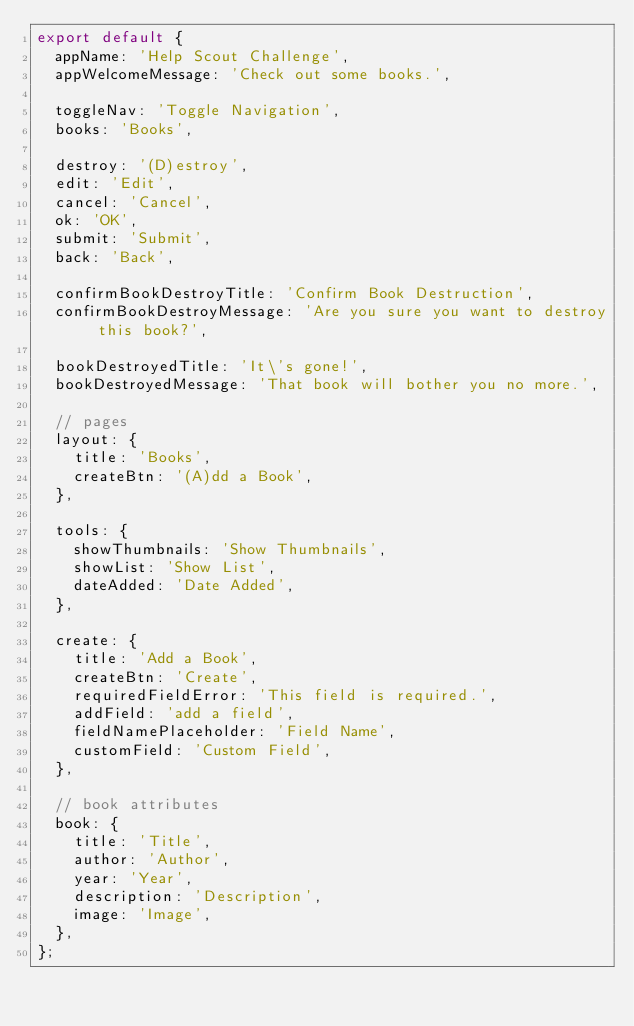<code> <loc_0><loc_0><loc_500><loc_500><_JavaScript_>export default {
  appName: 'Help Scout Challenge',
  appWelcomeMessage: 'Check out some books.',

  toggleNav: 'Toggle Navigation',
  books: 'Books',

  destroy: '(D)estroy',
  edit: 'Edit',
  cancel: 'Cancel',
  ok: 'OK',
  submit: 'Submit',
  back: 'Back',

  confirmBookDestroyTitle: 'Confirm Book Destruction',
  confirmBookDestroyMessage: 'Are you sure you want to destroy this book?',

  bookDestroyedTitle: 'It\'s gone!',
  bookDestroyedMessage: 'That book will bother you no more.',

  // pages
  layout: {
    title: 'Books',
    createBtn: '(A)dd a Book',
  },

  tools: {
    showThumbnails: 'Show Thumbnails',
    showList: 'Show List',
    dateAdded: 'Date Added',
  },

  create: {
    title: 'Add a Book',
    createBtn: 'Create',
    requiredFieldError: 'This field is required.',
    addField: 'add a field',
    fieldNamePlaceholder: 'Field Name',
    customField: 'Custom Field',
  },

  // book attributes
  book: {
    title: 'Title',
    author: 'Author',
    year: 'Year',
    description: 'Description',
    image: 'Image',
  },
};
</code> 